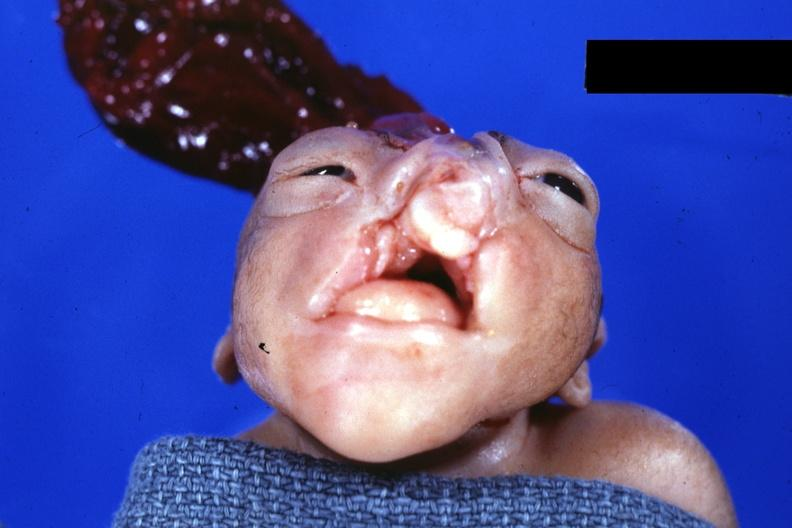does this image show frontal view close-up?
Answer the question using a single word or phrase. Yes 